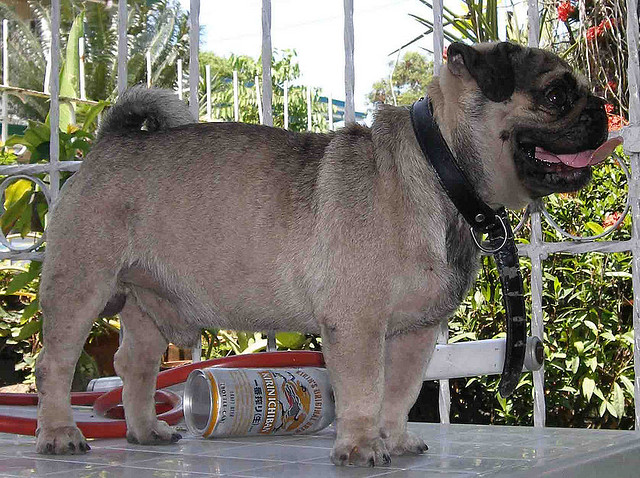Please extract the text content from this image. KIRIN CHIBAK 